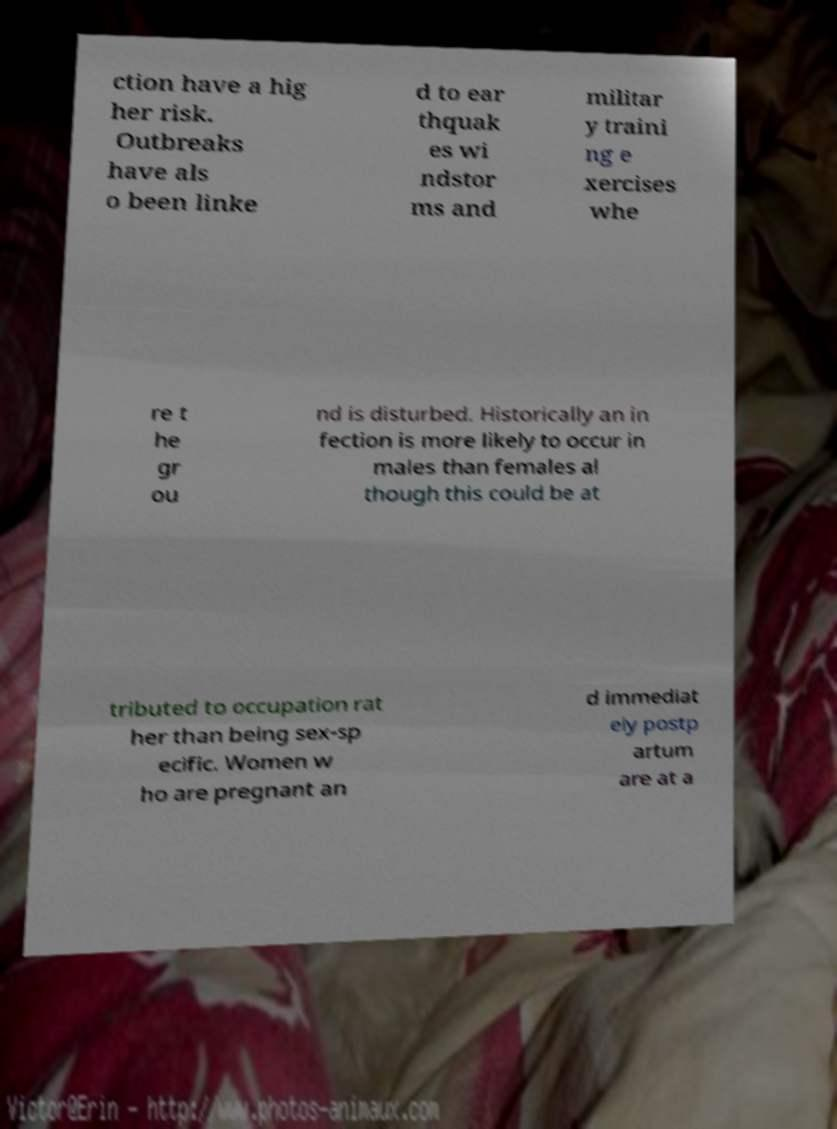Please identify and transcribe the text found in this image. ction have a hig her risk. Outbreaks have als o been linke d to ear thquak es wi ndstor ms and militar y traini ng e xercises whe re t he gr ou nd is disturbed. Historically an in fection is more likely to occur in males than females al though this could be at tributed to occupation rat her than being sex-sp ecific. Women w ho are pregnant an d immediat ely postp artum are at a 